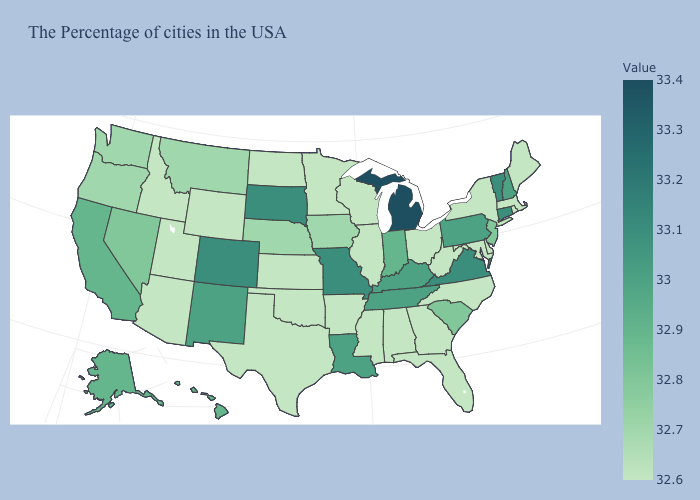Which states have the lowest value in the MidWest?
Quick response, please. Ohio, Wisconsin, Illinois, Minnesota, Kansas, North Dakota. Which states have the lowest value in the West?
Give a very brief answer. Wyoming, Utah, Arizona, Idaho. Does Virginia have a higher value than Michigan?
Short answer required. No. Among the states that border Idaho , does Wyoming have the lowest value?
Keep it brief. Yes. Among the states that border Oregon , which have the lowest value?
Quick response, please. Idaho. Does Texas have a higher value than Vermont?
Concise answer only. No. Among the states that border Nevada , which have the lowest value?
Short answer required. Utah, Arizona, Idaho. Which states have the lowest value in the USA?
Be succinct. Maine, Massachusetts, Rhode Island, New York, Delaware, Maryland, North Carolina, West Virginia, Ohio, Florida, Georgia, Alabama, Wisconsin, Illinois, Mississippi, Arkansas, Minnesota, Kansas, Oklahoma, Texas, North Dakota, Wyoming, Utah, Arizona, Idaho. Does New Jersey have the highest value in the Northeast?
Quick response, please. No. 